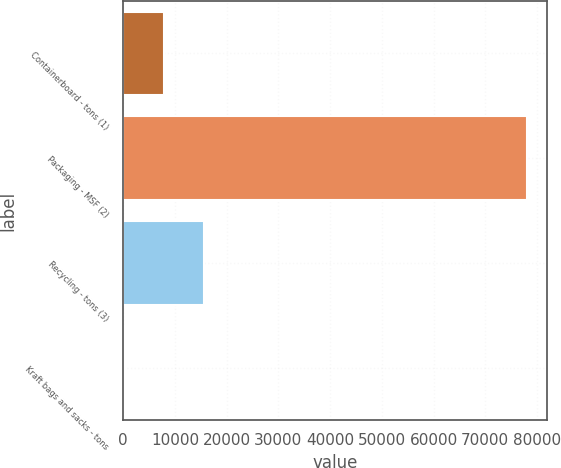Convert chart. <chart><loc_0><loc_0><loc_500><loc_500><bar_chart><fcel>Containerboard - tons (1)<fcel>Packaging - MSF (2)<fcel>Recycling - tons (3)<fcel>Kraft bags and sacks - tons<nl><fcel>7888.1<fcel>78089<fcel>15688.2<fcel>88<nl></chart> 